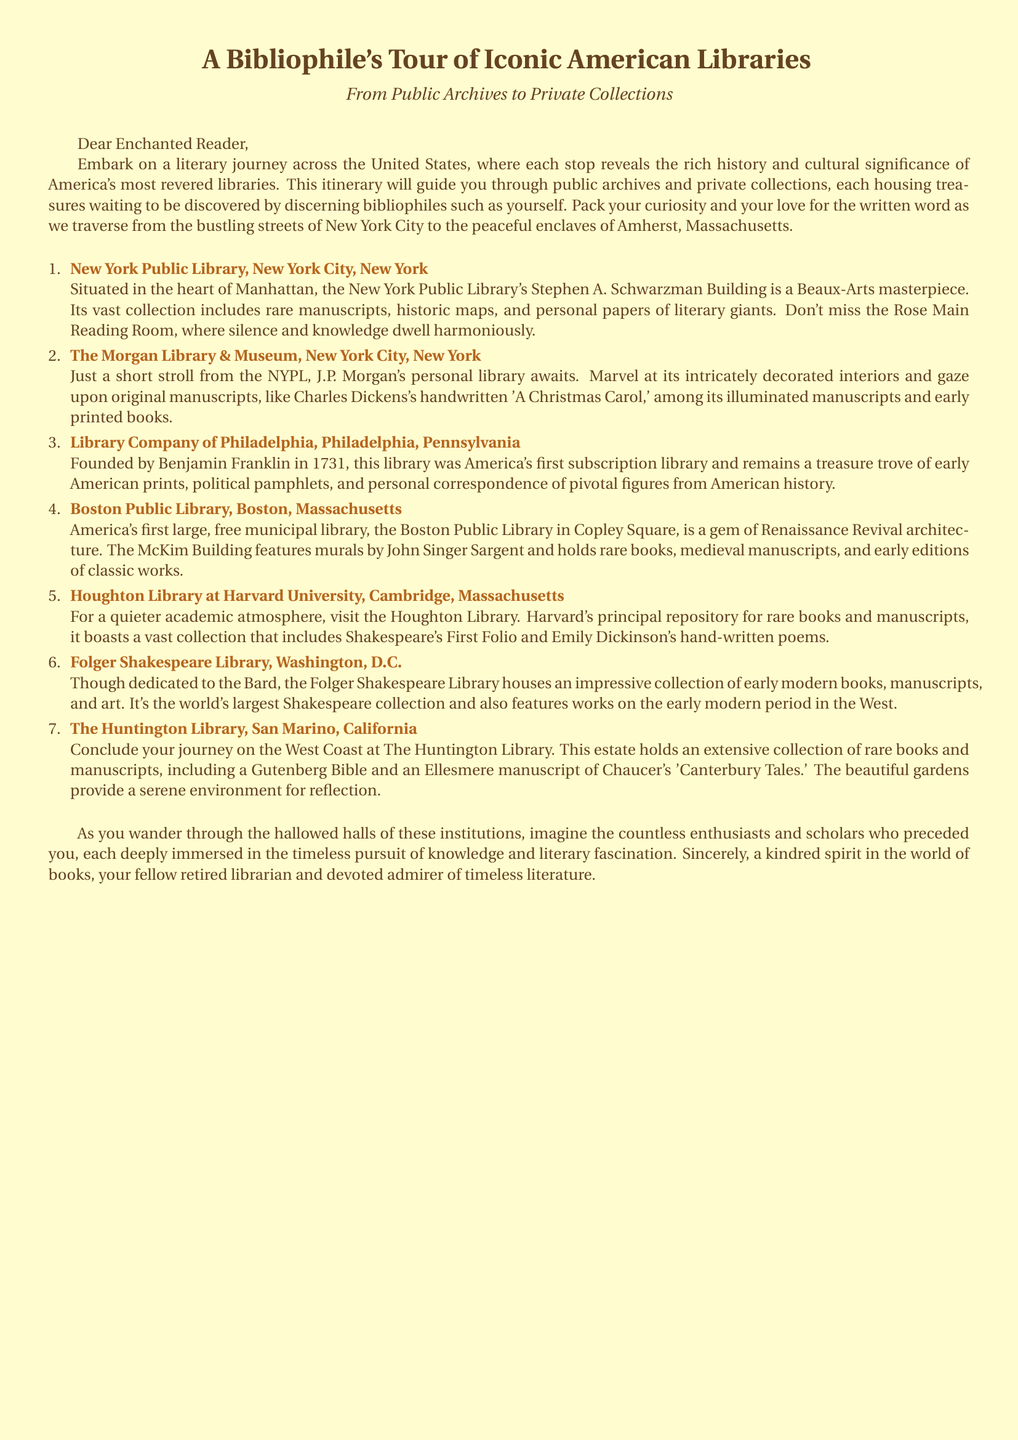What is the first library mentioned in the itinerary? The first library listed in the itinerary is the New York Public Library.
Answer: New York Public Library Which author’s handwritten manuscript can be found in The Morgan Library? The Morgan Library features a handwritten manuscript of "A Christmas Carol" by Charles Dickens.
Answer: Charles Dickens How many libraries are included in the tour? The itinerary includes a total of seven libraries.
Answer: Seven What significant historical figure founded the Library Company of Philadelphia? The Library Company of Philadelphia was founded by Benjamin Franklin.
Answer: Benjamin Franklin Which library contains Shakespeare's First Folio? The Houghton Library at Harvard University is where Shakespeare's First Folio is housed.
Answer: Houghton Library at Harvard University What type of architecture is the Boston Public Library known for? The Boston Public Library is known for its Renaissance Revival architecture.
Answer: Renaissance Revival What is the unique collection focus of the Folger Shakespeare Library? The Folger Shakespeare Library is focused on the world's largest collection of Shakespeare works.
Answer: Shakespeare What type of items does The Huntington Library house? The Huntington Library houses rare books and manuscripts.
Answer: Rare books and manuscripts 